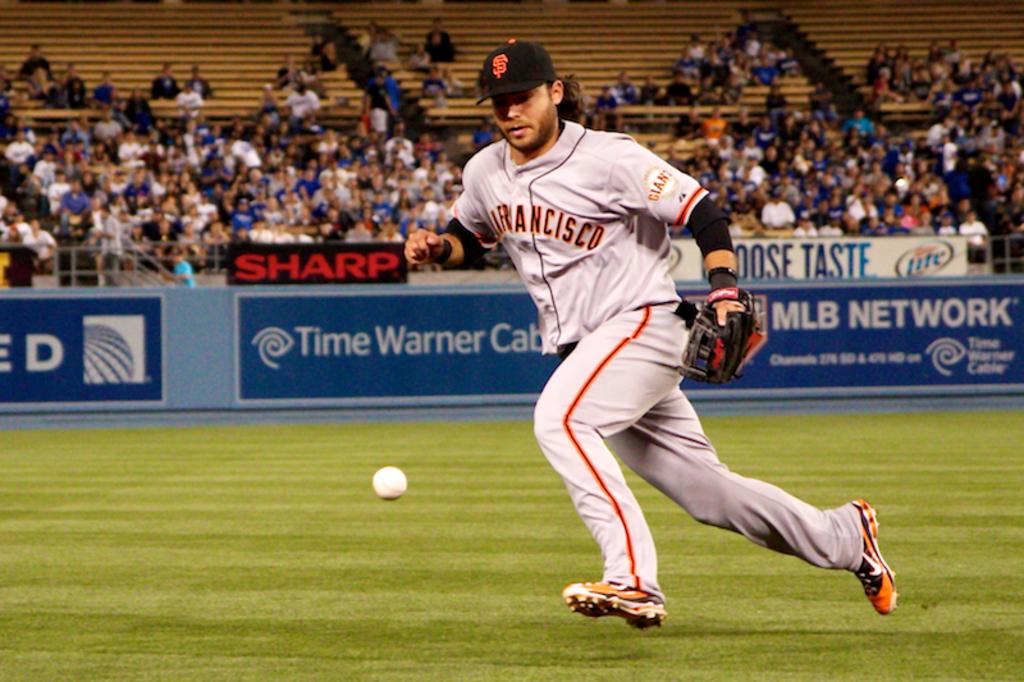Provide a one-sentence caption for the provided image. The player is from the San Francisco Giants. 